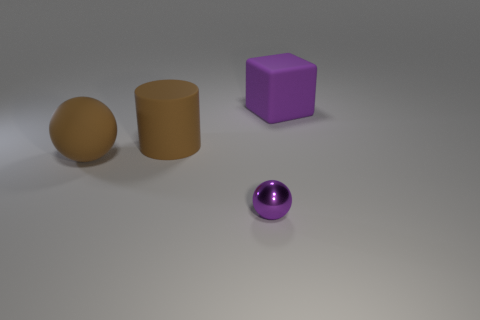Is there any other thing that has the same material as the tiny sphere?
Keep it short and to the point. No. Is the big cylinder the same color as the big rubber ball?
Your answer should be very brief. Yes. There is a thing that is in front of the ball that is to the left of the small purple metallic sphere; what size is it?
Offer a terse response. Small. Is the number of large brown matte spheres on the left side of the big ball less than the number of matte objects on the left side of the large rubber cube?
Offer a very short reply. Yes. The purple thing to the right of the purple thing that is in front of the large rubber cube is what shape?
Your response must be concise. Cube. Are there any big blue matte balls?
Make the answer very short. No. There is a thing to the right of the tiny purple ball; what color is it?
Offer a very short reply. Purple. What material is the thing that is the same color as the cube?
Your response must be concise. Metal. There is a purple cube; are there any purple objects in front of it?
Provide a short and direct response. Yes. Is the number of rubber cubes greater than the number of objects?
Offer a terse response. No. 